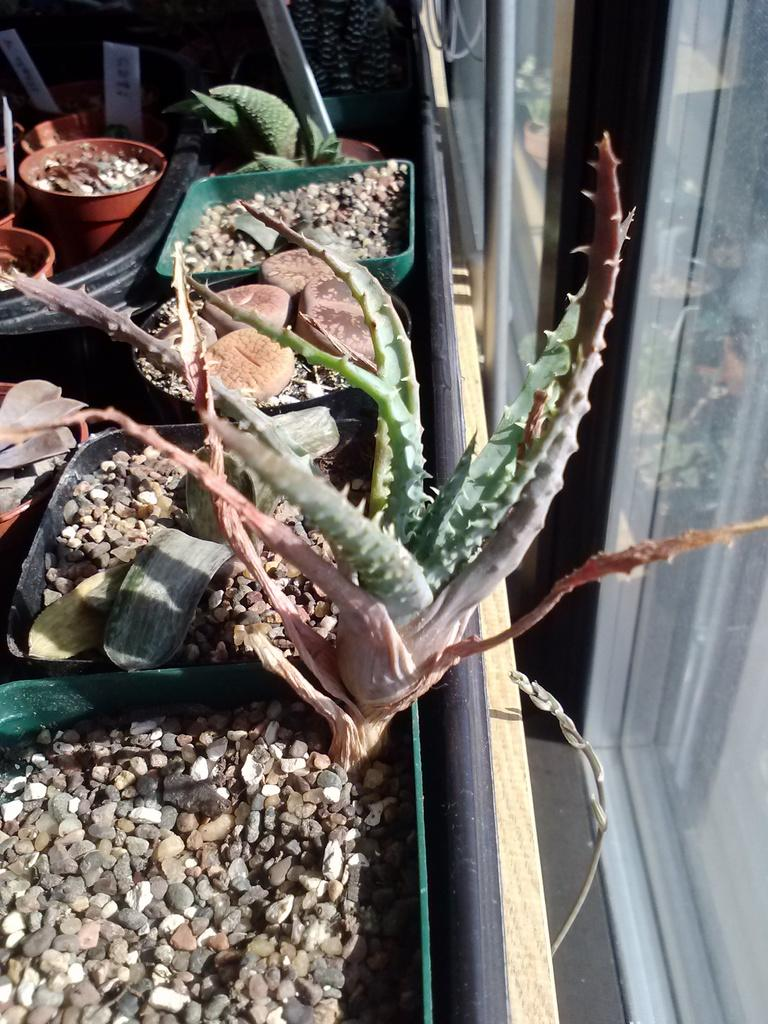What type of living organisms can be seen in the image? Plants can be seen in the image. What other objects are present in the image? There are stones and boards in the pots in the image. What type of grain is being harvested by the creator in the image? There is no creator or grain present in the image. Can you locate a map in the image? There is no map present in the image. 